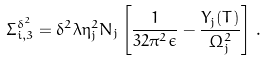<formula> <loc_0><loc_0><loc_500><loc_500>\Sigma _ { i , 3 } ^ { \delta ^ { 2 } } = \delta ^ { 2 } \lambda \eta _ { j } ^ { 2 } N _ { j } \left [ \frac { 1 } { 3 2 \pi ^ { 2 } \epsilon } - \frac { Y _ { j } ( T ) } { \Omega _ { j } ^ { 2 } } \right ] \, .</formula> 